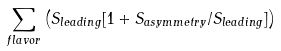<formula> <loc_0><loc_0><loc_500><loc_500>\sum _ { f l a v o r } \left ( S _ { l e a d i n g } [ 1 + S _ { a s y m m e t r y } / S _ { l e a d i n g } ] \right )</formula> 